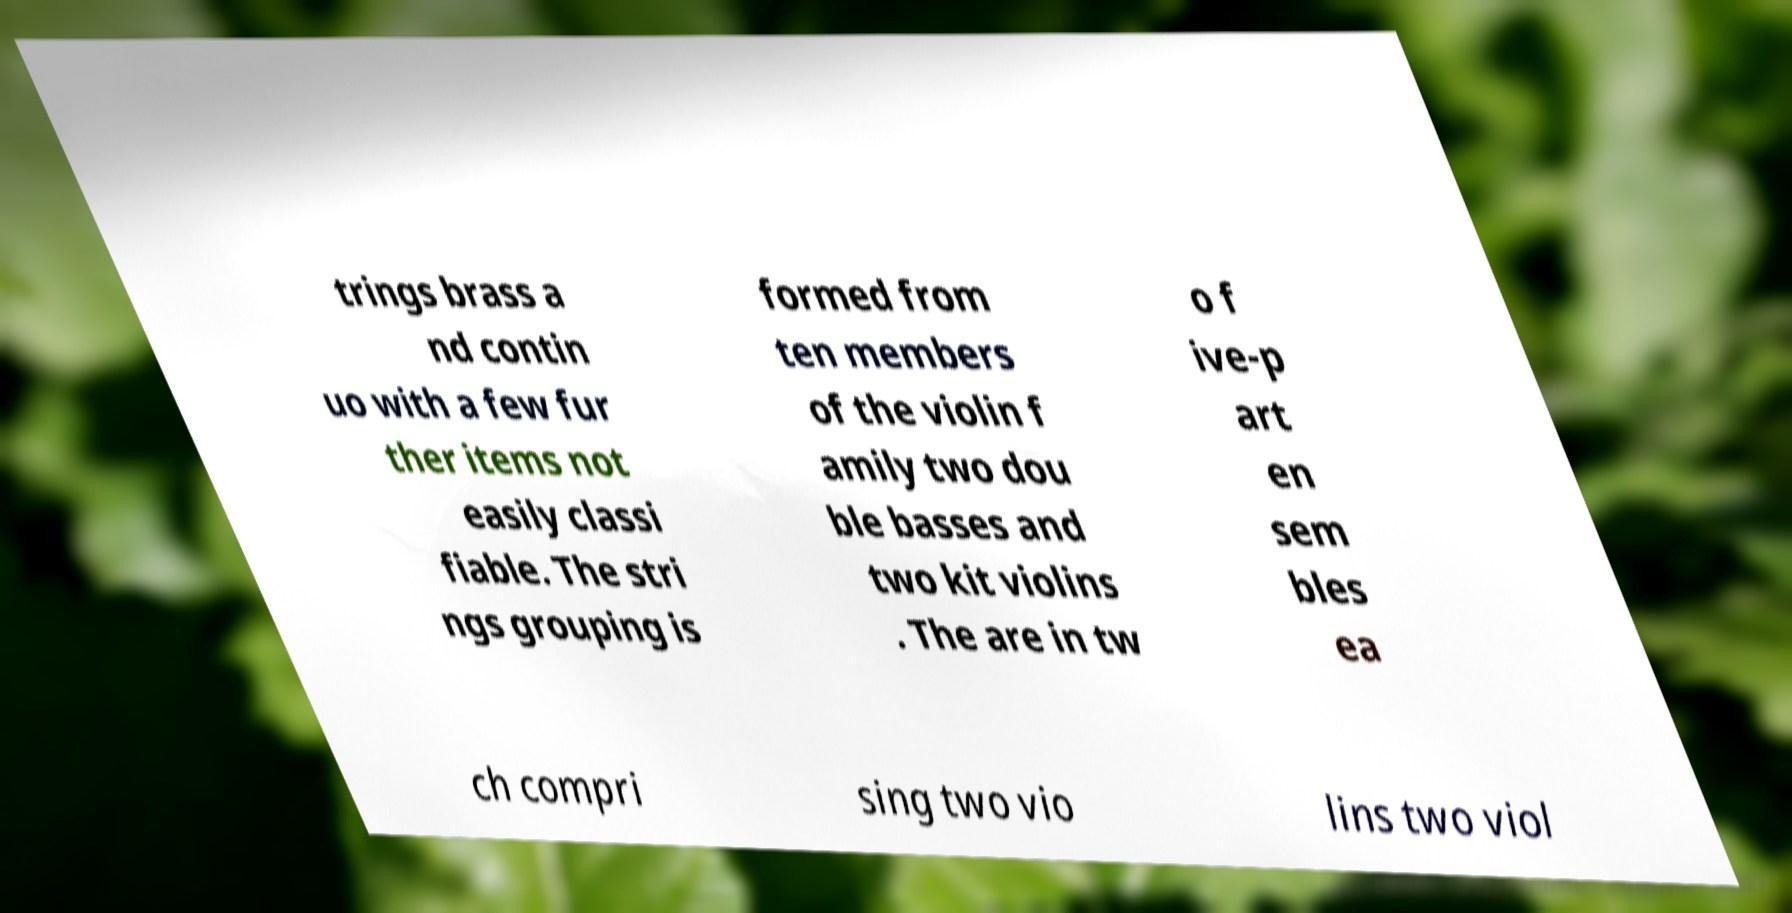There's text embedded in this image that I need extracted. Can you transcribe it verbatim? trings brass a nd contin uo with a few fur ther items not easily classi fiable. The stri ngs grouping is formed from ten members of the violin f amily two dou ble basses and two kit violins . The are in tw o f ive-p art en sem bles ea ch compri sing two vio lins two viol 